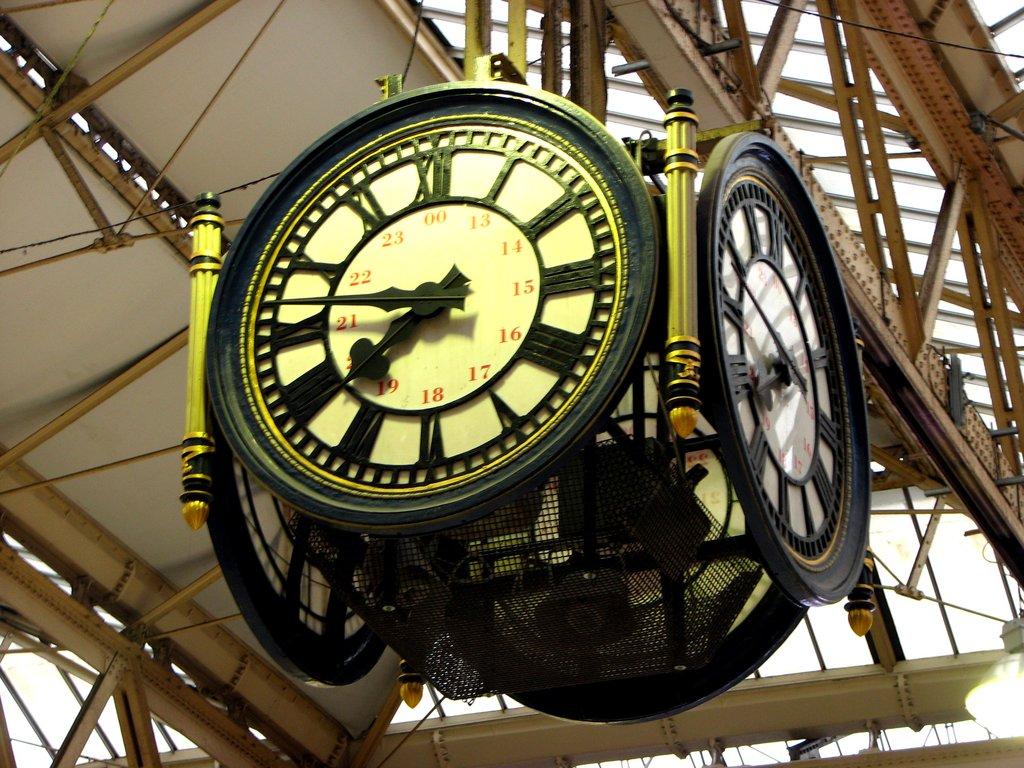What time does the clock read?
Provide a succinct answer. 7:46. What number is at the top of the clock?
Ensure brevity in your answer.  00. 